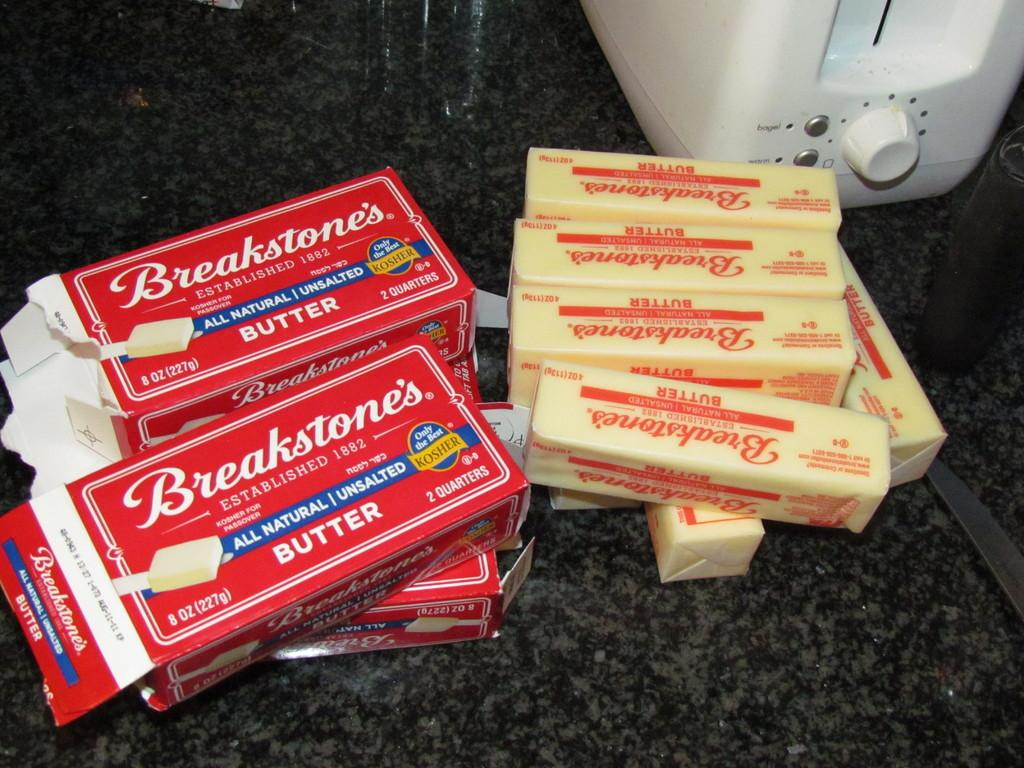Provide a one-sentence caption for the provided image. The contents of several Breakstone Butter boxes lie on a counter. 